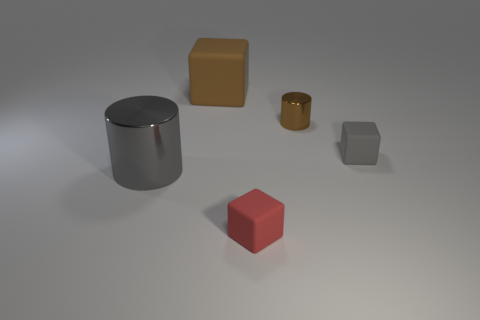What number of shiny objects are behind the gray thing left of the small matte thing on the right side of the tiny metal thing?
Provide a short and direct response. 1. What is the color of the cylinder that is the same size as the gray cube?
Offer a terse response. Brown. Is the number of small matte blocks behind the tiny gray matte object greater than the number of brown matte cubes?
Provide a succinct answer. No. Is the material of the small brown thing the same as the big cylinder?
Keep it short and to the point. Yes. How many objects are cubes behind the gray metal cylinder or rubber objects?
Make the answer very short. 3. What number of other things are there of the same size as the brown matte thing?
Ensure brevity in your answer.  1. Is the number of red things behind the tiny red matte cube the same as the number of big gray shiny cylinders in front of the gray cylinder?
Your answer should be compact. Yes. What is the color of the other tiny object that is the same shape as the tiny gray object?
Make the answer very short. Red. Is there anything else that is the same shape as the tiny gray object?
Provide a succinct answer. Yes. There is a small shiny cylinder on the left side of the small gray thing; does it have the same color as the large rubber thing?
Give a very brief answer. Yes. 